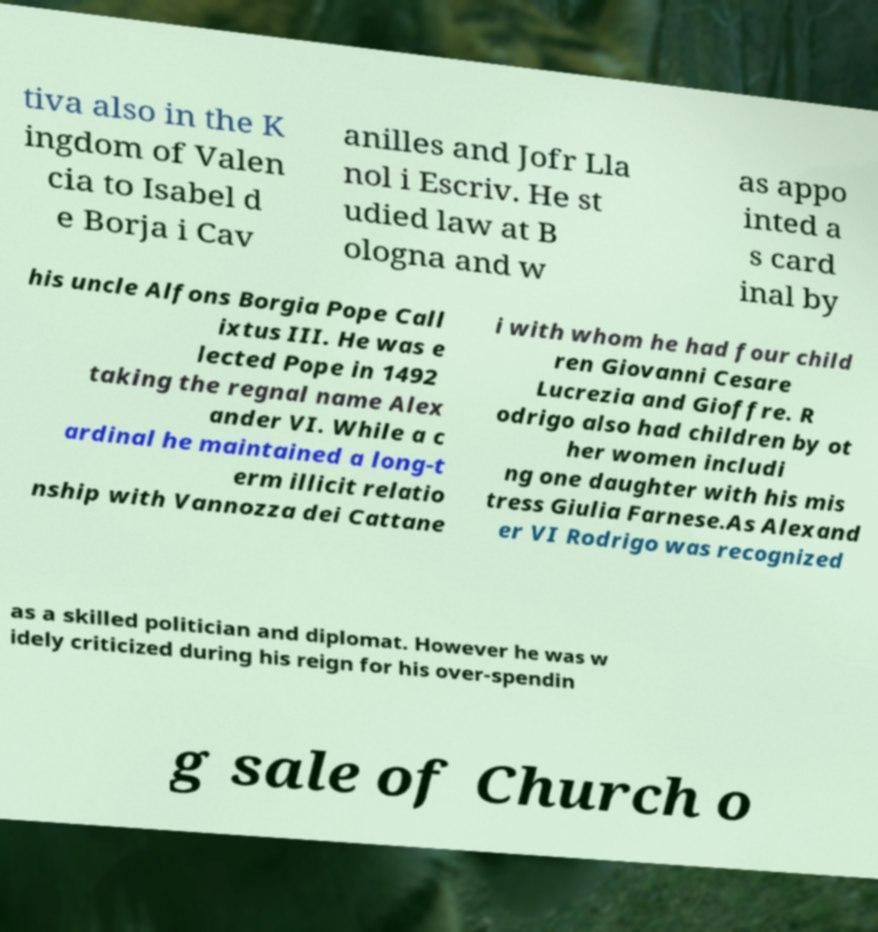Please identify and transcribe the text found in this image. tiva also in the K ingdom of Valen cia to Isabel d e Borja i Cav anilles and Jofr Lla nol i Escriv. He st udied law at B ologna and w as appo inted a s card inal by his uncle Alfons Borgia Pope Call ixtus III. He was e lected Pope in 1492 taking the regnal name Alex ander VI. While a c ardinal he maintained a long-t erm illicit relatio nship with Vannozza dei Cattane i with whom he had four child ren Giovanni Cesare Lucrezia and Gioffre. R odrigo also had children by ot her women includi ng one daughter with his mis tress Giulia Farnese.As Alexand er VI Rodrigo was recognized as a skilled politician and diplomat. However he was w idely criticized during his reign for his over-spendin g sale of Church o 